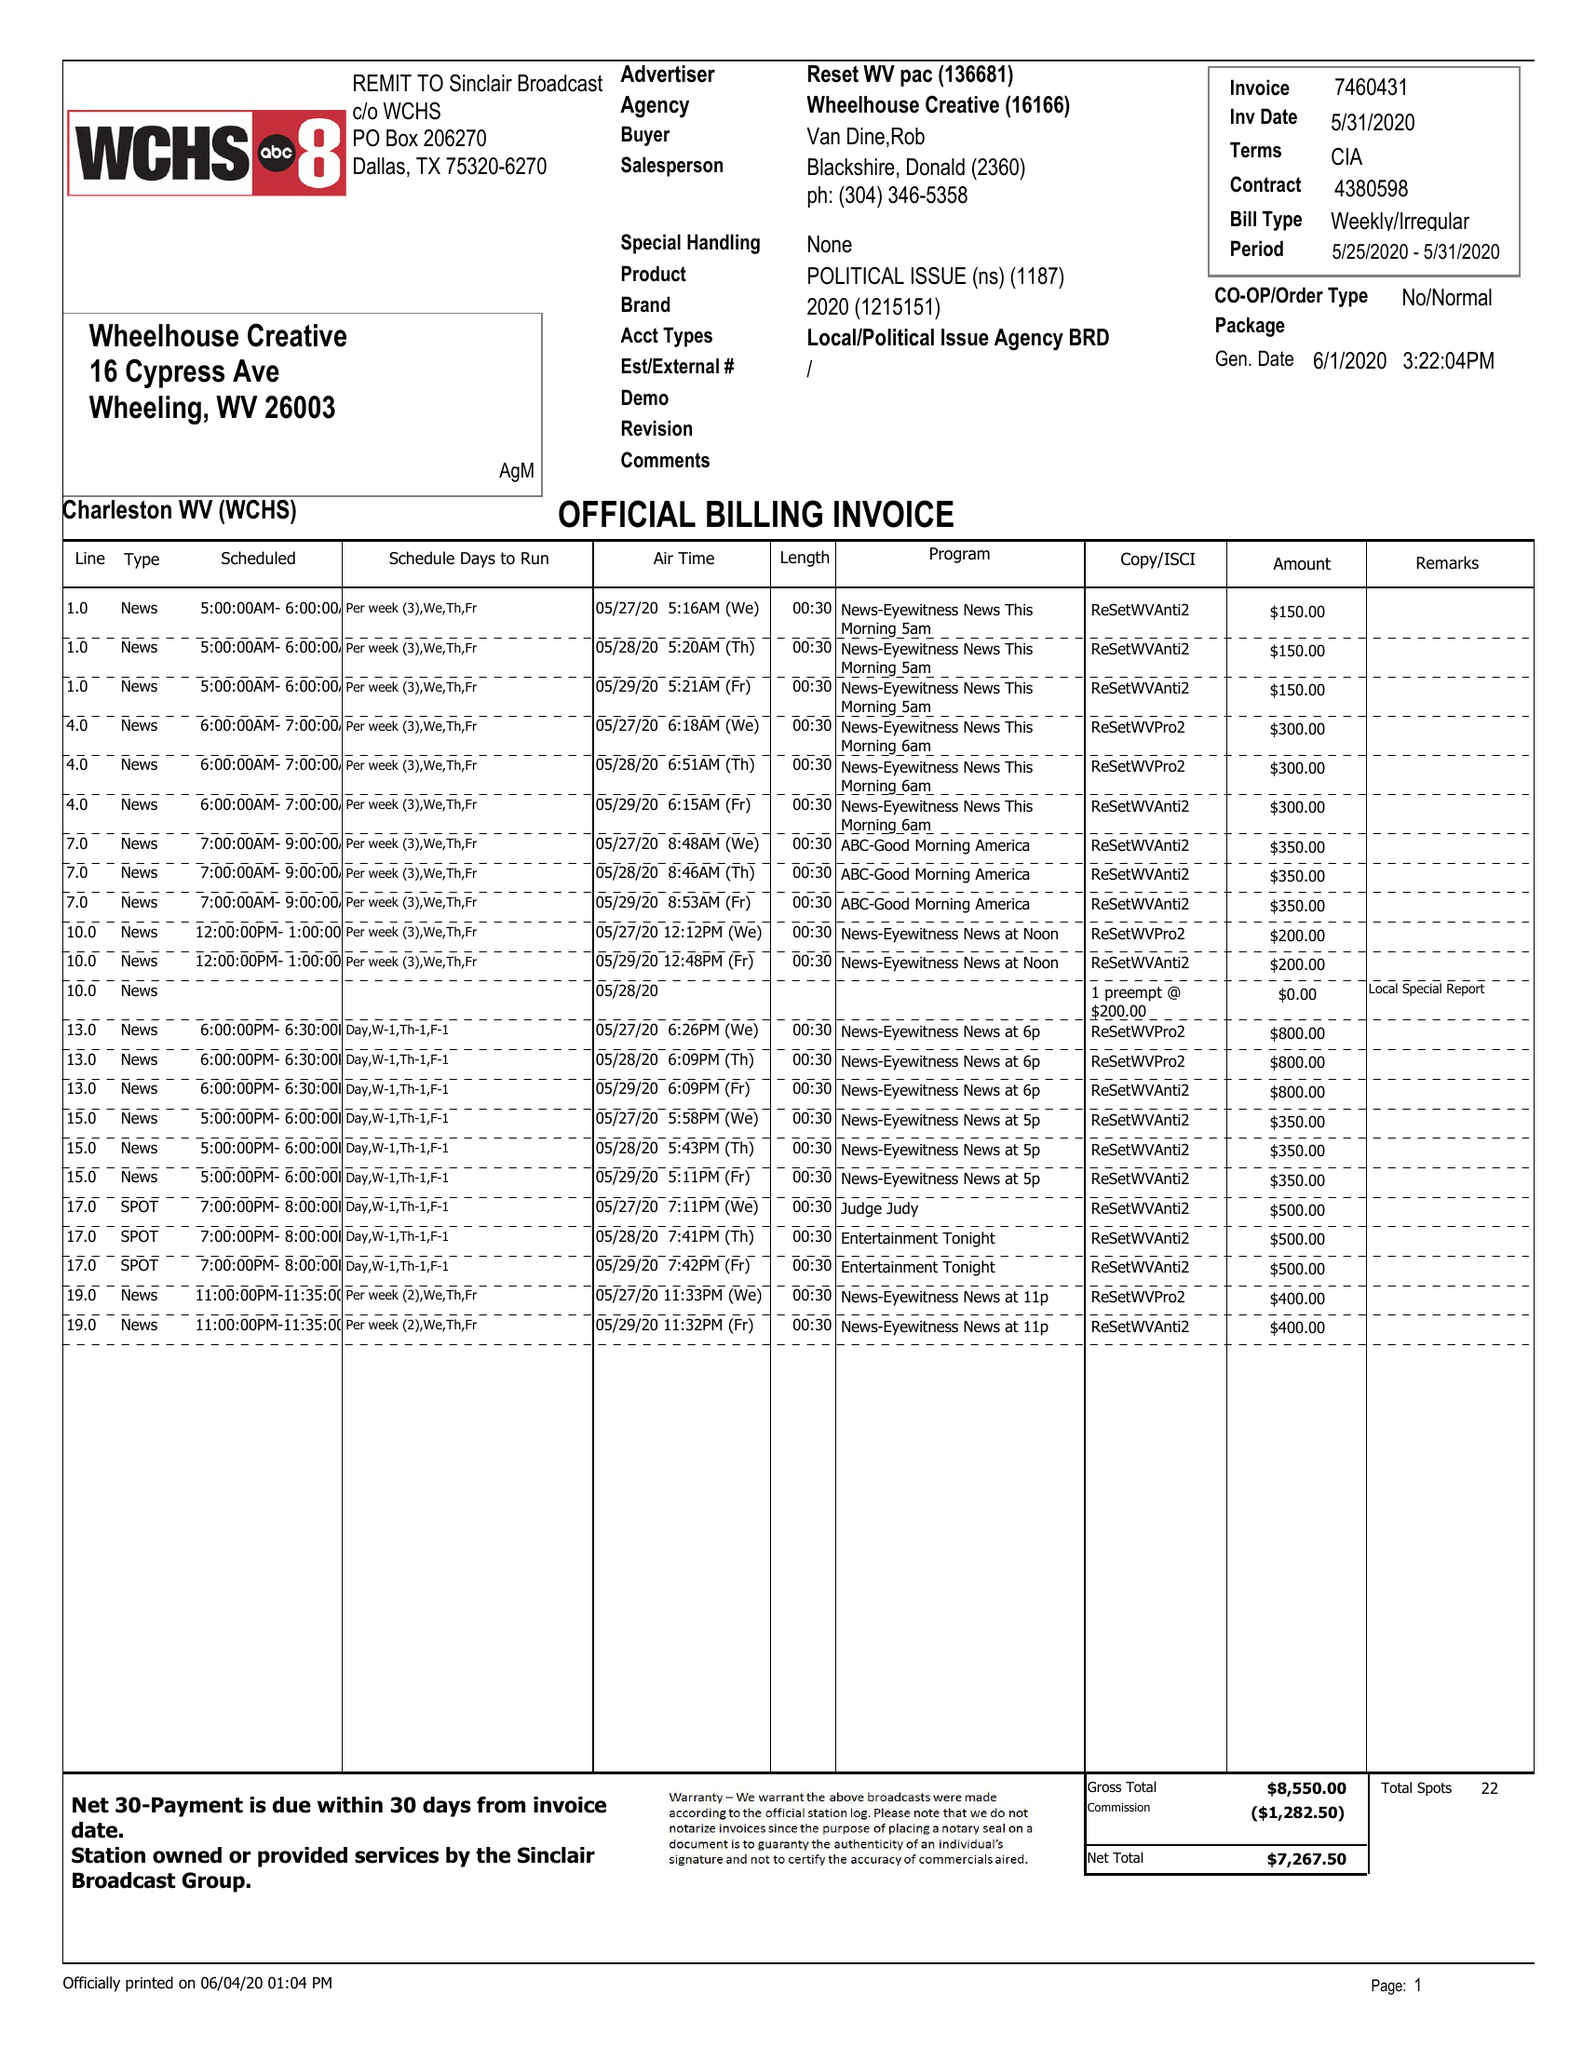What is the value for the flight_to?
Answer the question using a single word or phrase. 05/31/20 